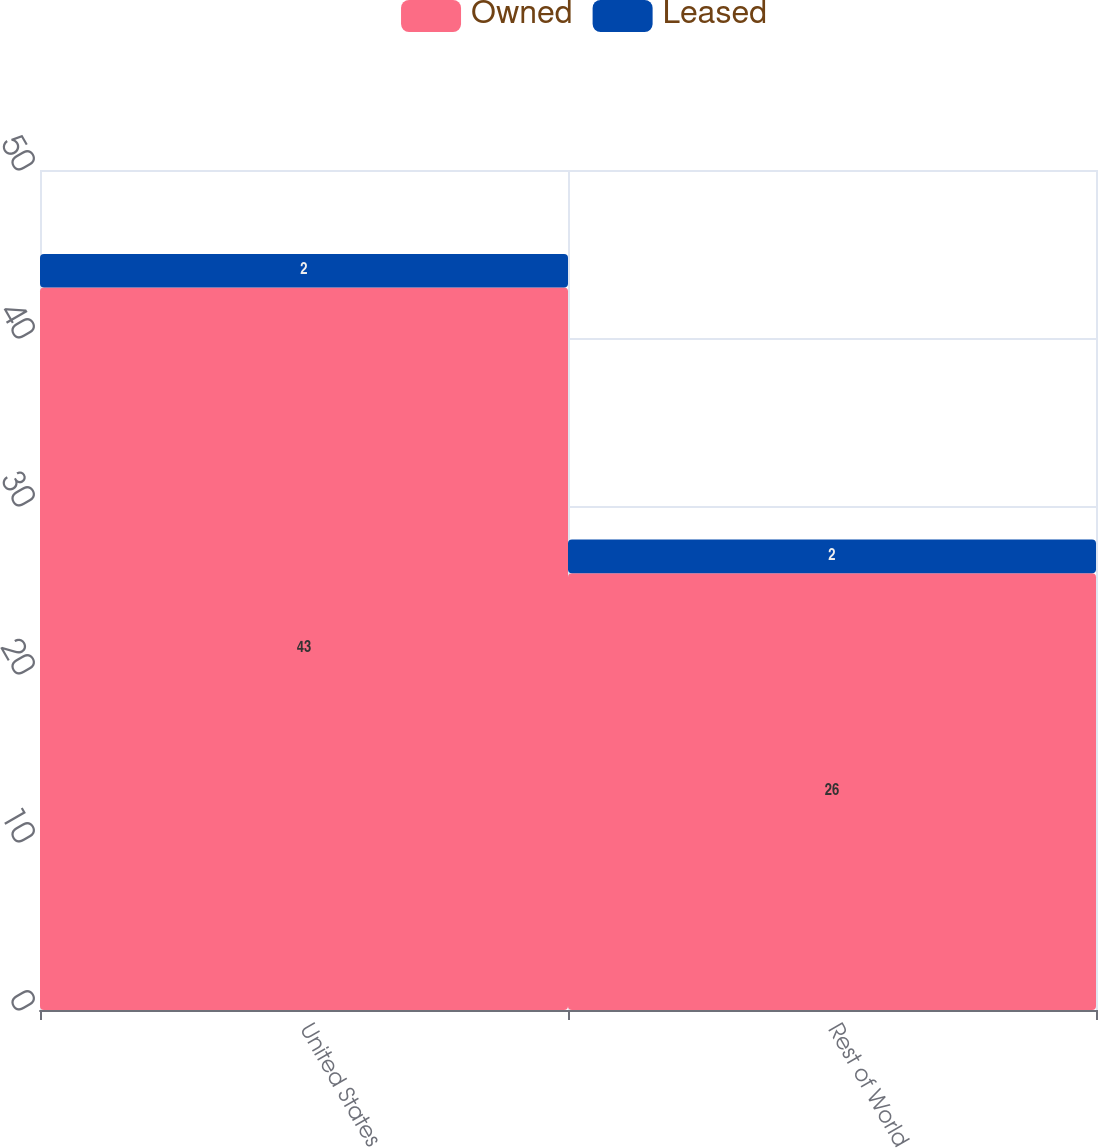Convert chart. <chart><loc_0><loc_0><loc_500><loc_500><stacked_bar_chart><ecel><fcel>United States<fcel>Rest of World<nl><fcel>Owned<fcel>43<fcel>26<nl><fcel>Leased<fcel>2<fcel>2<nl></chart> 